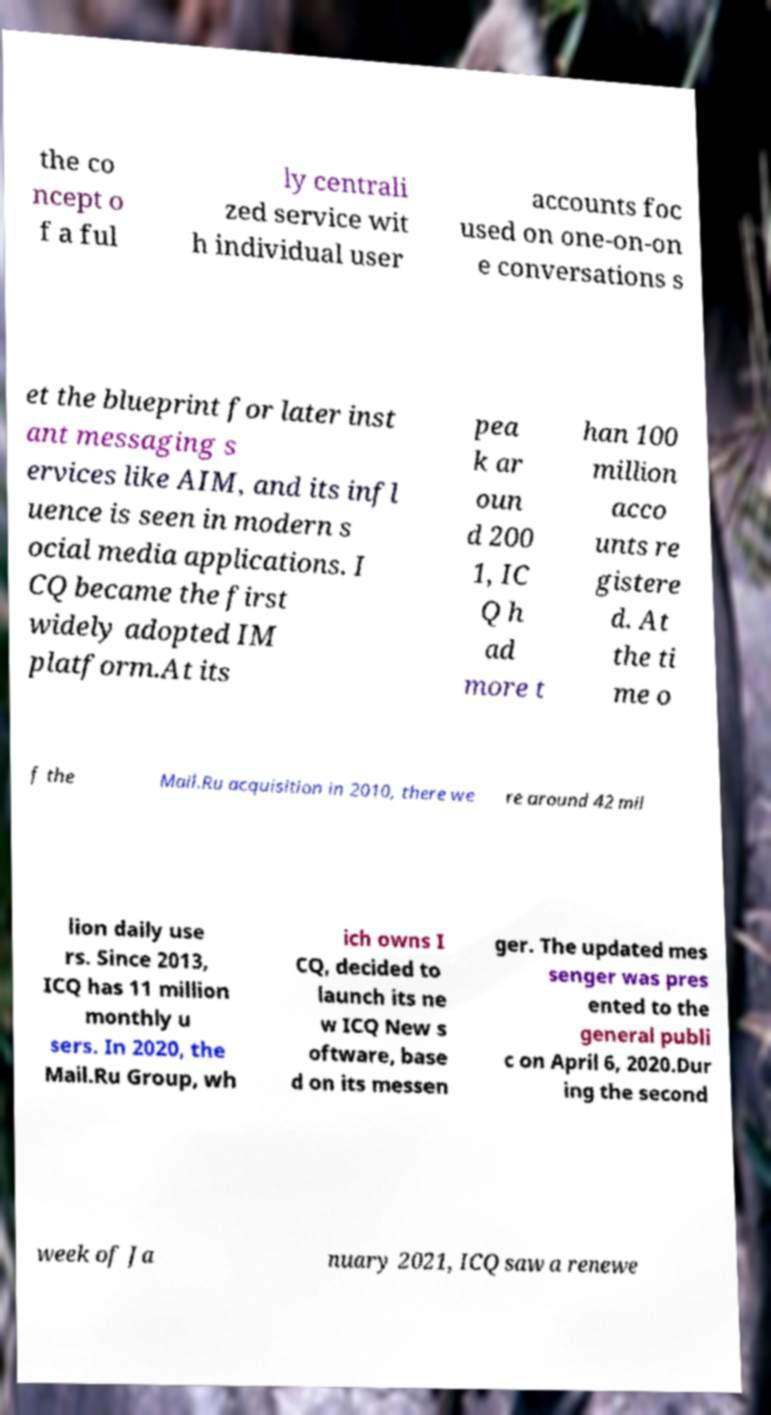Could you assist in decoding the text presented in this image and type it out clearly? the co ncept o f a ful ly centrali zed service wit h individual user accounts foc used on one-on-on e conversations s et the blueprint for later inst ant messaging s ervices like AIM, and its infl uence is seen in modern s ocial media applications. I CQ became the first widely adopted IM platform.At its pea k ar oun d 200 1, IC Q h ad more t han 100 million acco unts re gistere d. At the ti me o f the Mail.Ru acquisition in 2010, there we re around 42 mil lion daily use rs. Since 2013, ICQ has 11 million monthly u sers. In 2020, the Mail.Ru Group, wh ich owns I CQ, decided to launch its ne w ICQ New s oftware, base d on its messen ger. The updated mes senger was pres ented to the general publi c on April 6, 2020.Dur ing the second week of Ja nuary 2021, ICQ saw a renewe 